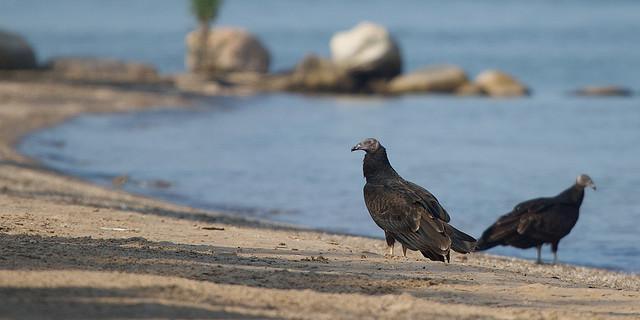How many birds are there?
Give a very brief answer. 2. 